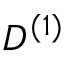Convert formula to latex. <formula><loc_0><loc_0><loc_500><loc_500>D ^ { ( 1 ) }</formula> 